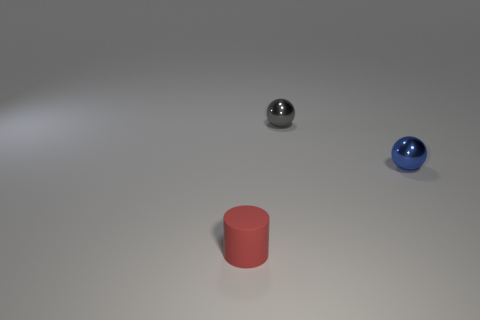How many blue metal things are the same size as the blue ball? Upon reviewing the image, it appears there are no other blue metal objects present that match the size of the blue ball. The ball is the only blue object of its kind in the image. 